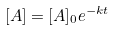Convert formula to latex. <formula><loc_0><loc_0><loc_500><loc_500>[ A ] = [ A ] _ { 0 } e ^ { - k t }</formula> 